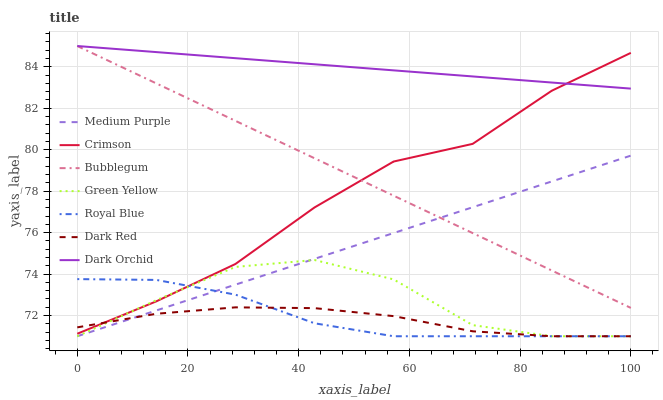Does Dark Red have the minimum area under the curve?
Answer yes or no. Yes. Does Dark Orchid have the maximum area under the curve?
Answer yes or no. Yes. Does Bubblegum have the minimum area under the curve?
Answer yes or no. No. Does Bubblegum have the maximum area under the curve?
Answer yes or no. No. Is Medium Purple the smoothest?
Answer yes or no. Yes. Is Green Yellow the roughest?
Answer yes or no. Yes. Is Bubblegum the smoothest?
Answer yes or no. No. Is Bubblegum the roughest?
Answer yes or no. No. Does Dark Red have the lowest value?
Answer yes or no. Yes. Does Bubblegum have the lowest value?
Answer yes or no. No. Does Dark Orchid have the highest value?
Answer yes or no. Yes. Does Medium Purple have the highest value?
Answer yes or no. No. Is Dark Red less than Bubblegum?
Answer yes or no. Yes. Is Bubblegum greater than Green Yellow?
Answer yes or no. Yes. Does Crimson intersect Royal Blue?
Answer yes or no. Yes. Is Crimson less than Royal Blue?
Answer yes or no. No. Is Crimson greater than Royal Blue?
Answer yes or no. No. Does Dark Red intersect Bubblegum?
Answer yes or no. No. 